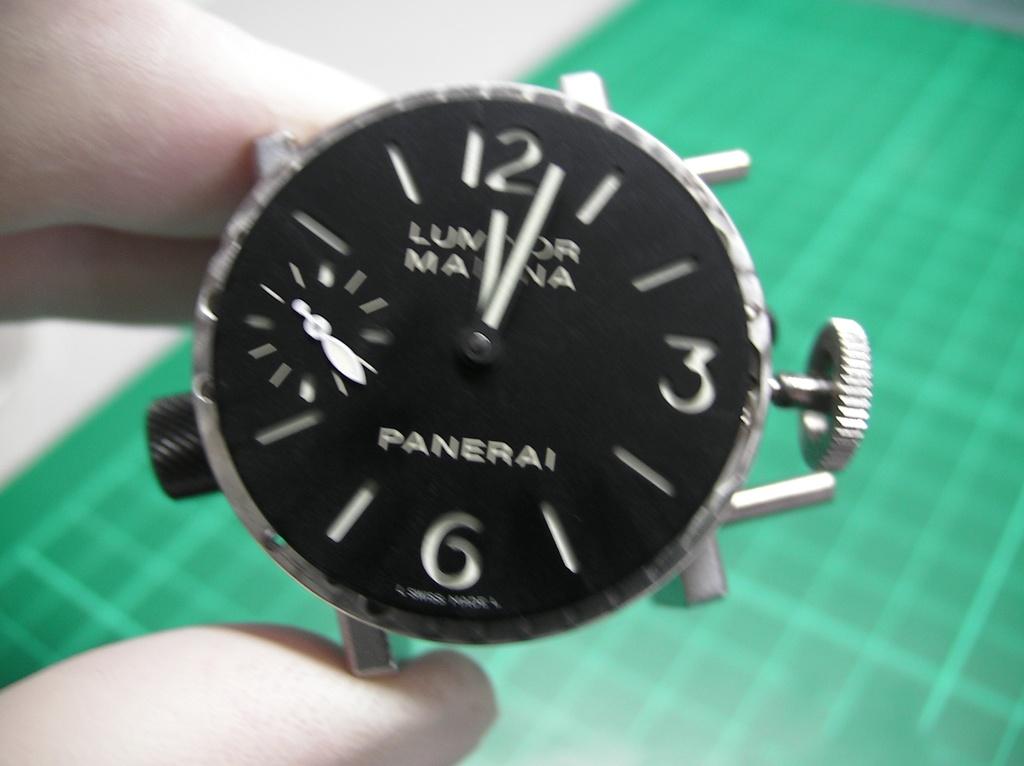What time is the watch set to?
Ensure brevity in your answer.  12:03. What kind of watch is this?
Give a very brief answer. Panerai. 